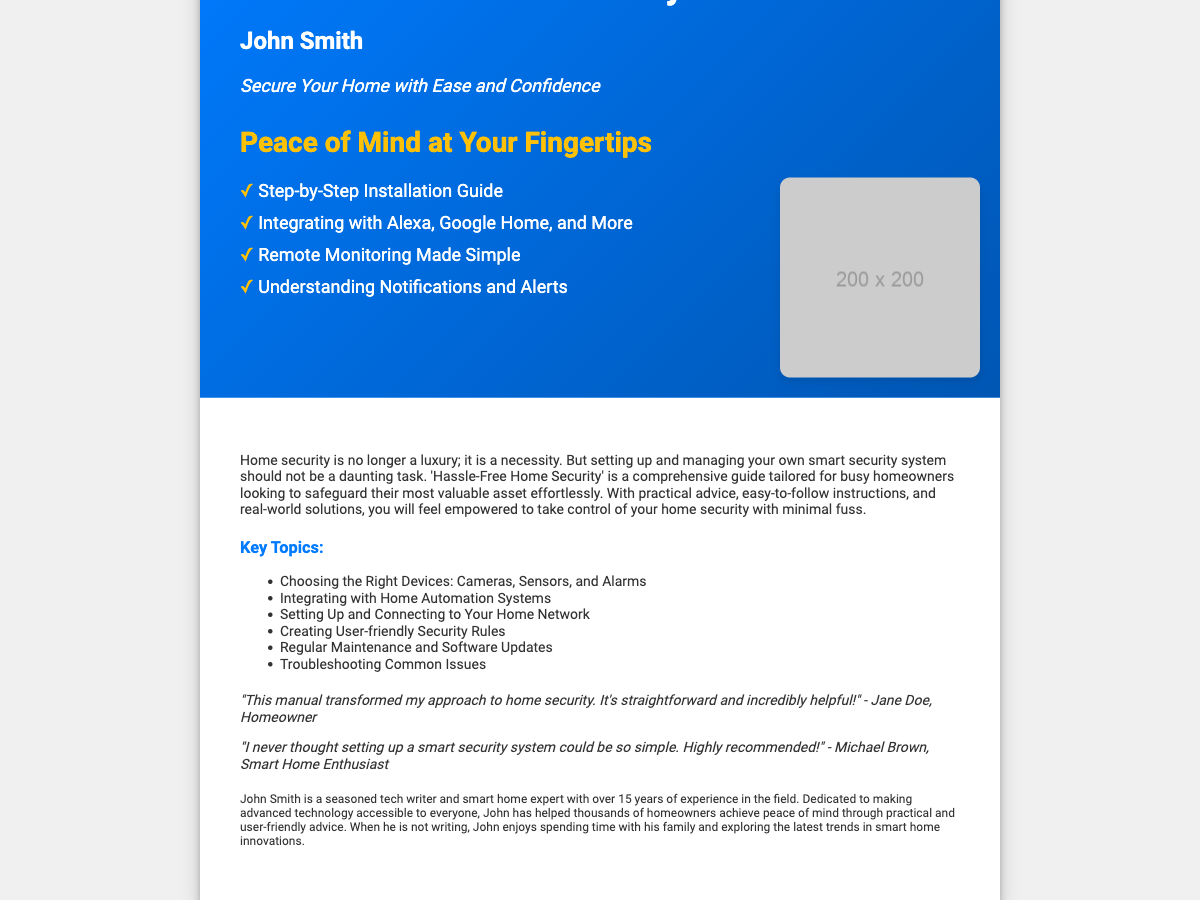What is the title of the book? The title of the book is prominently displayed at the top of the front cover.
Answer: Hassle-Free Home Security Who is the author of the book? The author's name is listed below the title on the front cover.
Answer: John Smith What is the tagline of the book? The tagline is an encouraging phrase located on the front cover beneath the author's name.
Answer: Secure Your Home with Ease and Confidence How many key topics are listed on the back cover? The number of key topics is indicated in a list format on the back cover.
Answer: Six Which smart home devices are mentioned for integration? The document lists types of smart home systems for integration.
Answer: Alexa, Google Home, and More What is the main focus of the book? The summary on the back cover clarifies the book's purpose.
Answer: Home security Who provided a testimonial for the book? Testimonials are noted in the back cover with names and roles.
Answer: Jane Doe, Homeowner How long has the author been a tech writer? The author's biography specifies the number of years of experience.
Answer: Over 15 years 